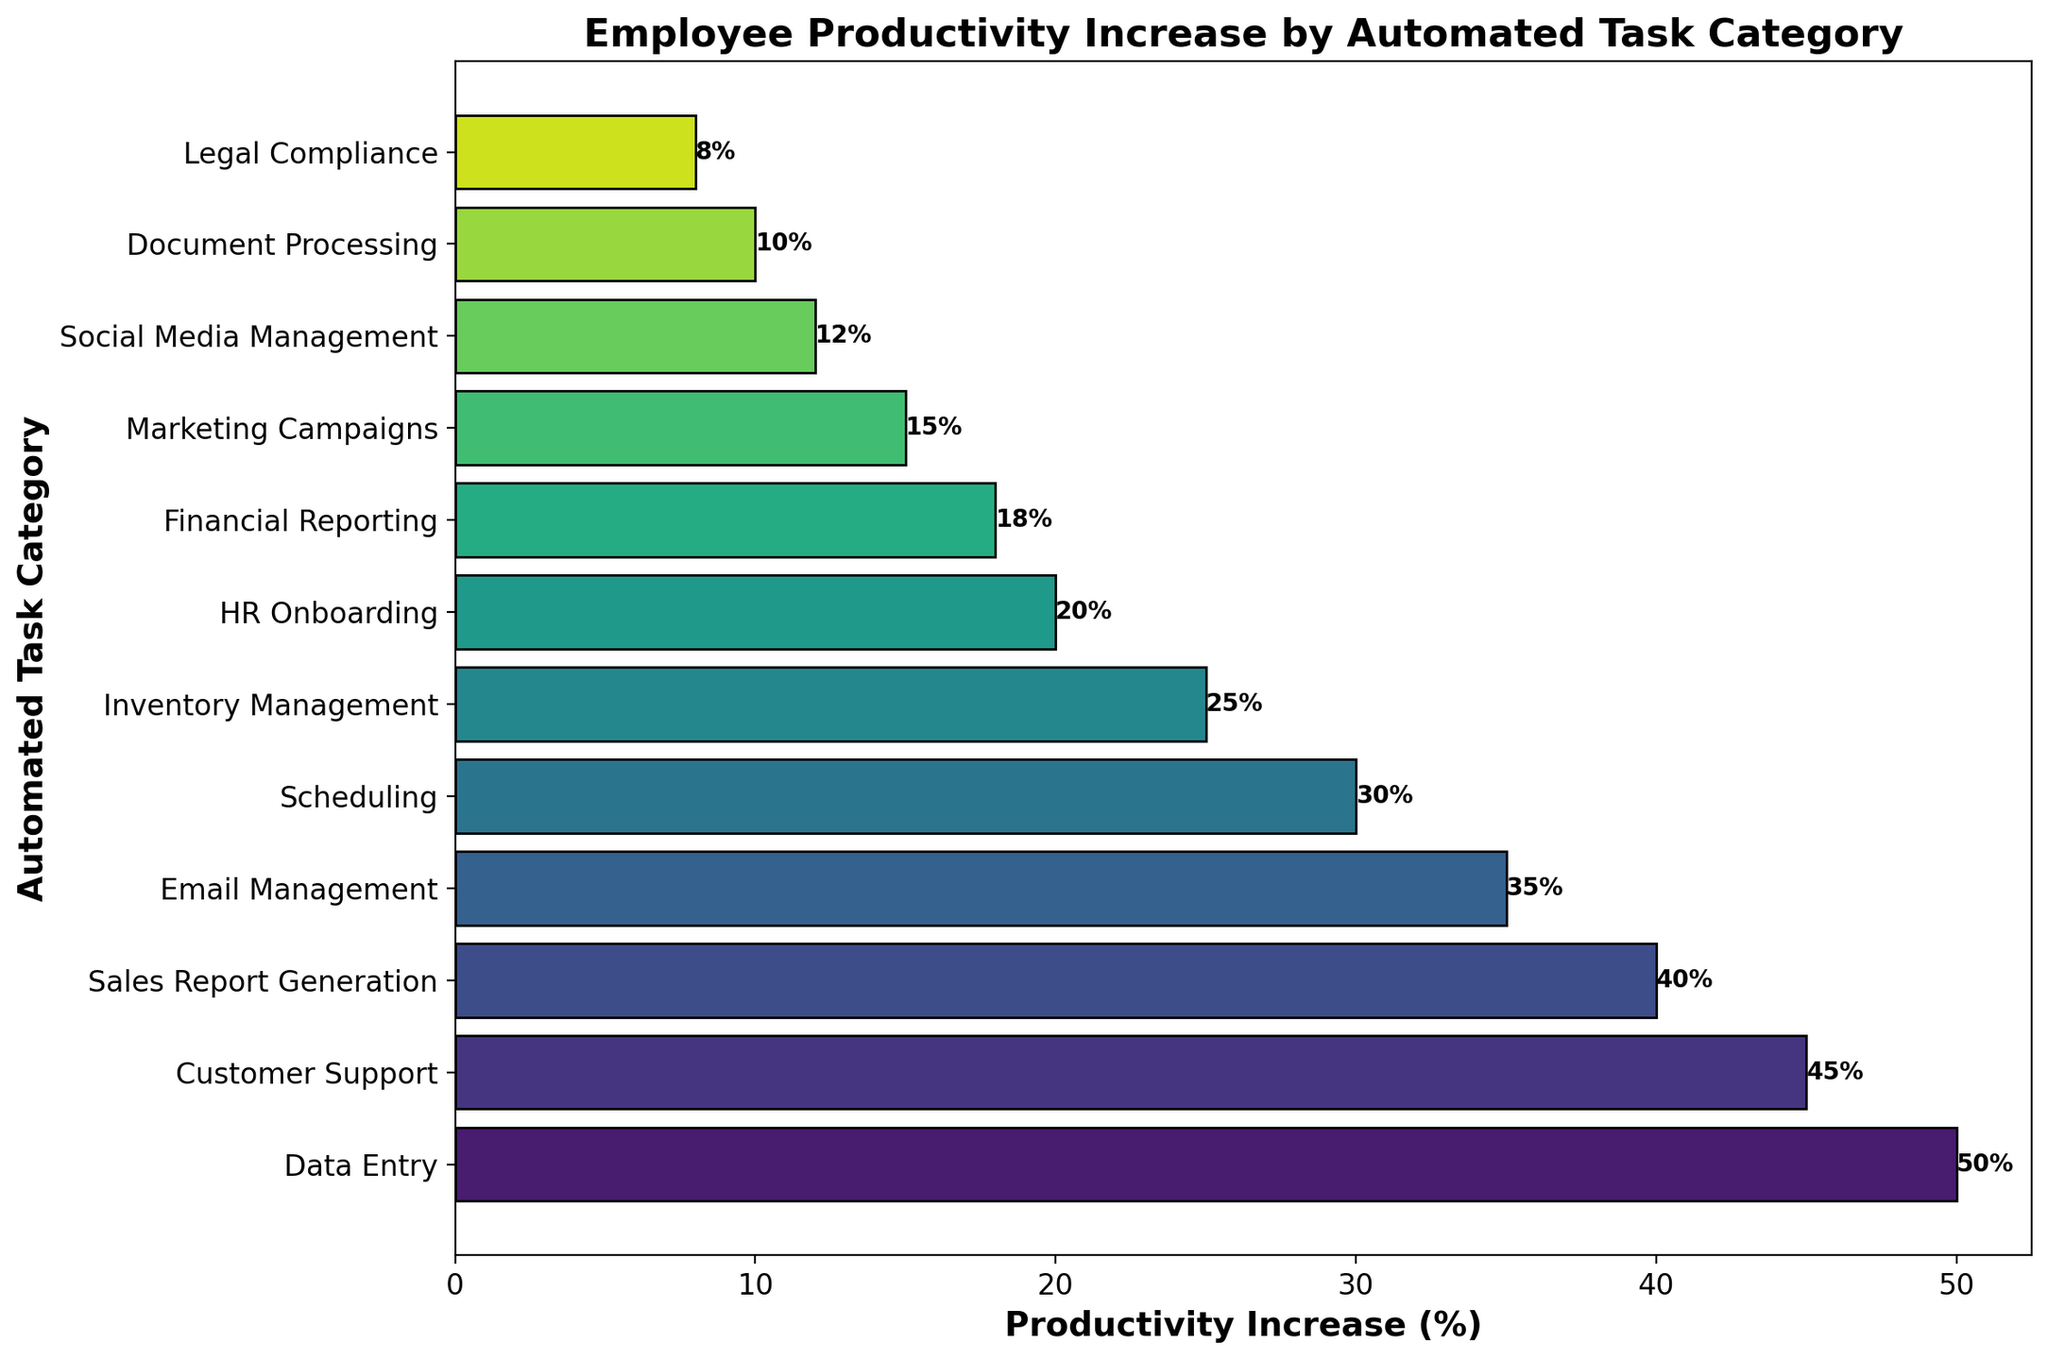Which automated task category has the highest productivity increase? By looking at the bar chart, the category with the longest bar represents the highest productivity increase. We can see that "Data Entry" has the longest bar with a productivity increase of 50%.
Answer: Data Entry Which automated task category has the lowest productivity increase? Referring to the bar chart, the category with the shortest bar represents the lowest productivity increase. "Legal Compliance" has the shortest bar with a productivity increase of 8%.
Answer: Legal Compliance How much higher is the productivity increase for "Data Entry" compared to "Customer Support"? "Data Entry" has a productivity increase of 50%, while "Customer Support" has a productivity increase of 45%. To find the difference, subtract the productivity increase of "Customer Support" from "Data Entry": 50% - 45% = 5%.
Answer: 5% What is the sum of the productivity increases for "Sales Report Generation," "Email Management," and "Scheduling"? The productivity increases for the respective categories are: "Sales Report Generation" (40%), "Email Management" (35%), and "Scheduling" (30%). Sum them up: 40% + 35% + 30% = 105%.
Answer: 105% Which categories have a productivity increase of more than 20% but less than 40%? From the bar chart, identify bars that fall within the range of 20% to 40%. These categories are: "Sales Report Generation" (40%), "Email Management" (35%), "Scheduling" (30%), and "Inventory Management" (25%).
Answer: Sales Report Generation, Email Management, Scheduling, Inventory Management What is the average productivity increase for all categories? Sum all productivity increase percentages and divide by the number of categories. The values are: 50%, 45%, 40%, 35%, 30%, 25%, 20%, 18%, 15%, 12%, 10%, 8%. The total is 308%. There are 12 categories, so the average is 308% / 12 = 25.67%.
Answer: 25.67% Rank the top three categories in terms of productivity increase. Referring to the figure, the top three categories with the highest bars are: 1) "Data Entry" (50%), 2) "Customer Support" (45%), and 3) "Sales Report Generation" (40%).
Answer: Data Entry, Customer Support, Sales Report Generation How does the productivity increase of "HR Onboarding" compare to "Financial Reporting"? "HR Onboarding" shows a productivity increase of 20%, and "Financial Reporting" shows a productivity increase of 18%. "HR Onboarding" has a higher productivity increase by 2%.
Answer: HR Onboarding has a 2% higher productivity increase than Financial Reporting What is the median productivity increase among the listed categories? Arrange the productivity increases in ascending order: 8%, 10%, 12%, 15%, 18%, 20%, 25%, 30%, 35%, 40%, 45%, 50%. The median value for an even number set is the average of the 6th and 7th values: (20% + 25%) / 2 = 22.5%.
Answer: 22.5% Which task categories have bars colored similarly, and what does that indicate? From the chart, "Financial Reporting," "Marketing Campaigns," and "Social Media Management" have bars in similar shades of color near the end of the "viridis" palette, indicating similar and relatively lower productivity increases in the range of 12% to 18%.
Answer: Financial Reporting, Marketing Campaigns, Social Media Management 